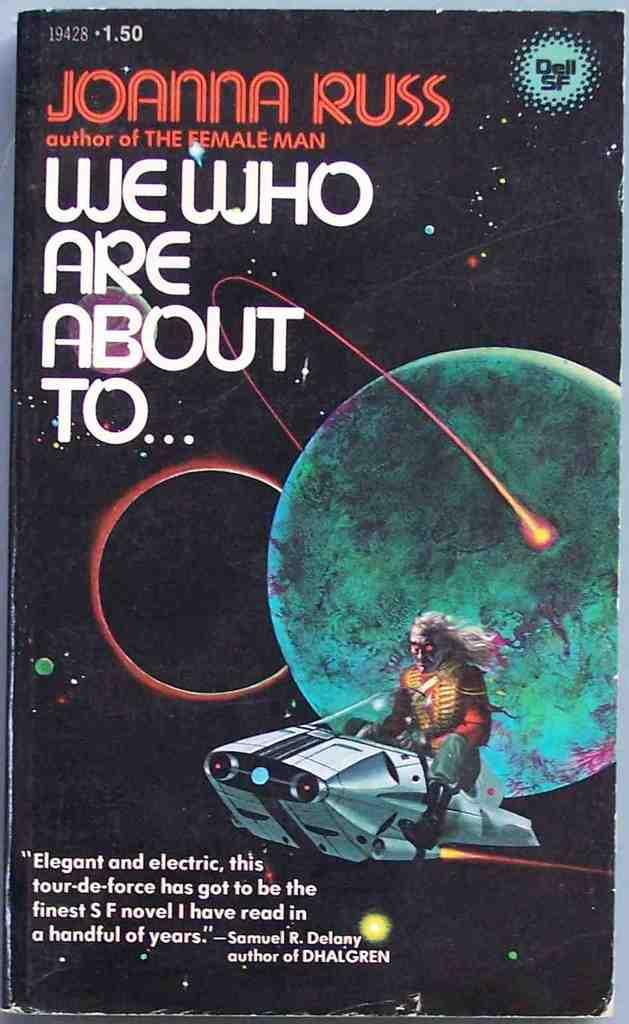<image>
Offer a succinct explanation of the picture presented. Book by Joanna Russ called we who are about to. 